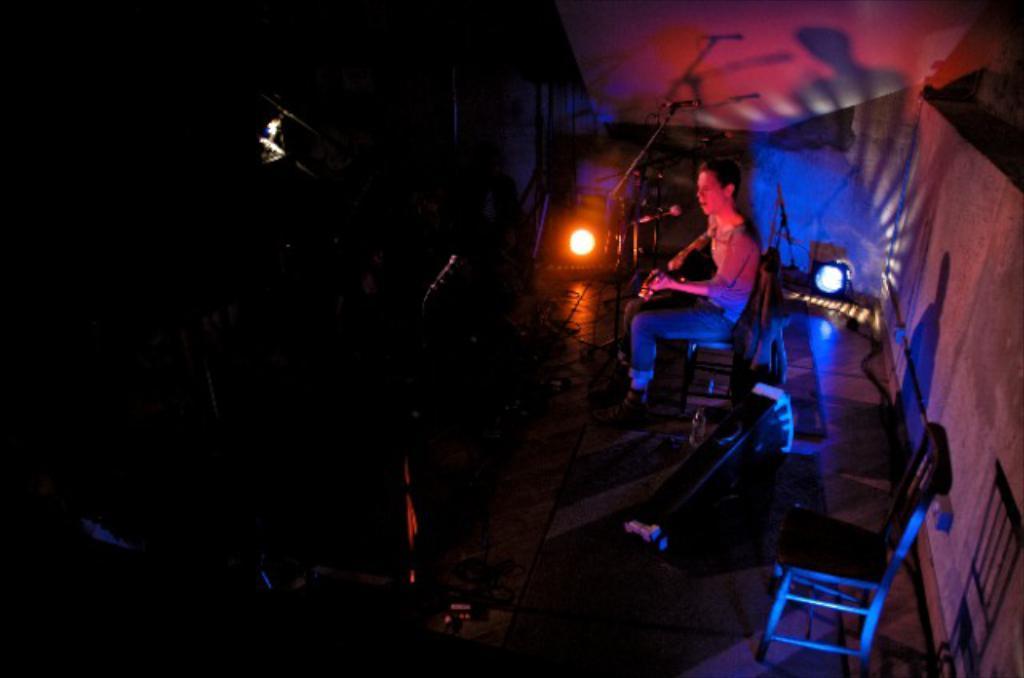In one or two sentences, can you explain what this image depicts? Here a man is playing guitar and singing on mic,around him there are musical instruments and light. 